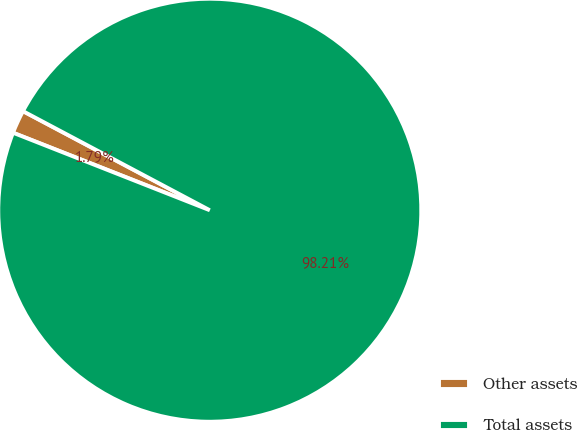Convert chart to OTSL. <chart><loc_0><loc_0><loc_500><loc_500><pie_chart><fcel>Other assets<fcel>Total assets<nl><fcel>1.79%<fcel>98.21%<nl></chart> 